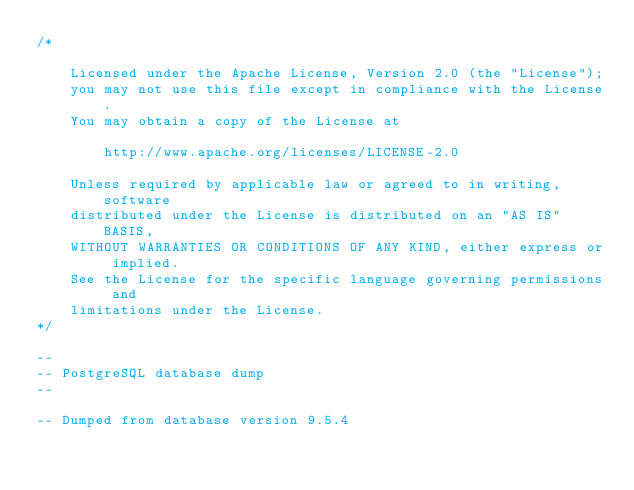<code> <loc_0><loc_0><loc_500><loc_500><_SQL_>/*

    Licensed under the Apache License, Version 2.0 (the "License");
    you may not use this file except in compliance with the License.
    You may obtain a copy of the License at

        http://www.apache.org/licenses/LICENSE-2.0

    Unless required by applicable law or agreed to in writing, software
    distributed under the License is distributed on an "AS IS" BASIS,
    WITHOUT WARRANTIES OR CONDITIONS OF ANY KIND, either express or implied.
    See the License for the specific language governing permissions and
    limitations under the License.
*/

--
-- PostgreSQL database dump
--

-- Dumped from database version 9.5.4</code> 